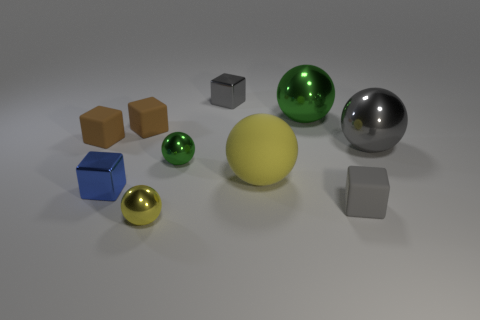There is a small shiny thing that is behind the large green shiny object; what color is it? The small shiny object situated behind the large green one appears to be silver or chrome, reflecting the environment with a high sheen, which gives it a neutral, metallic hue. 